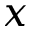<formula> <loc_0><loc_0><loc_500><loc_500>x</formula> 